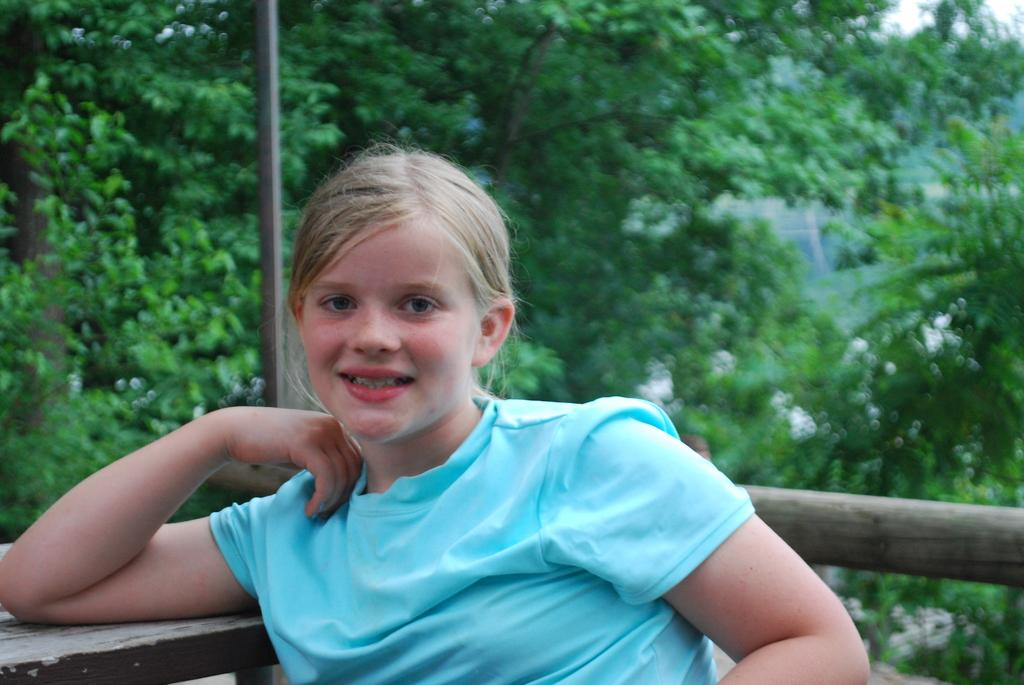Who is present in the image? There is a girl in the image. What is the girl doing in the image? The girl is smiling in the image. What can be seen in the background of the image? There is a pole and trees in the background of the image. What is located on the left side of the image? There is a table on the left side of the image. What type of water-based game is the girl playing in the image? There is no water or game present in the image; it features a girl smiling with a pole and trees in the background. 